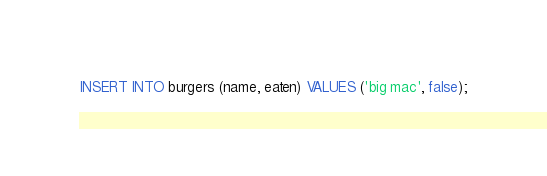Convert code to text. <code><loc_0><loc_0><loc_500><loc_500><_SQL_>INSERT INTO burgers (name, eaten) VALUES ('big mac', false);</code> 